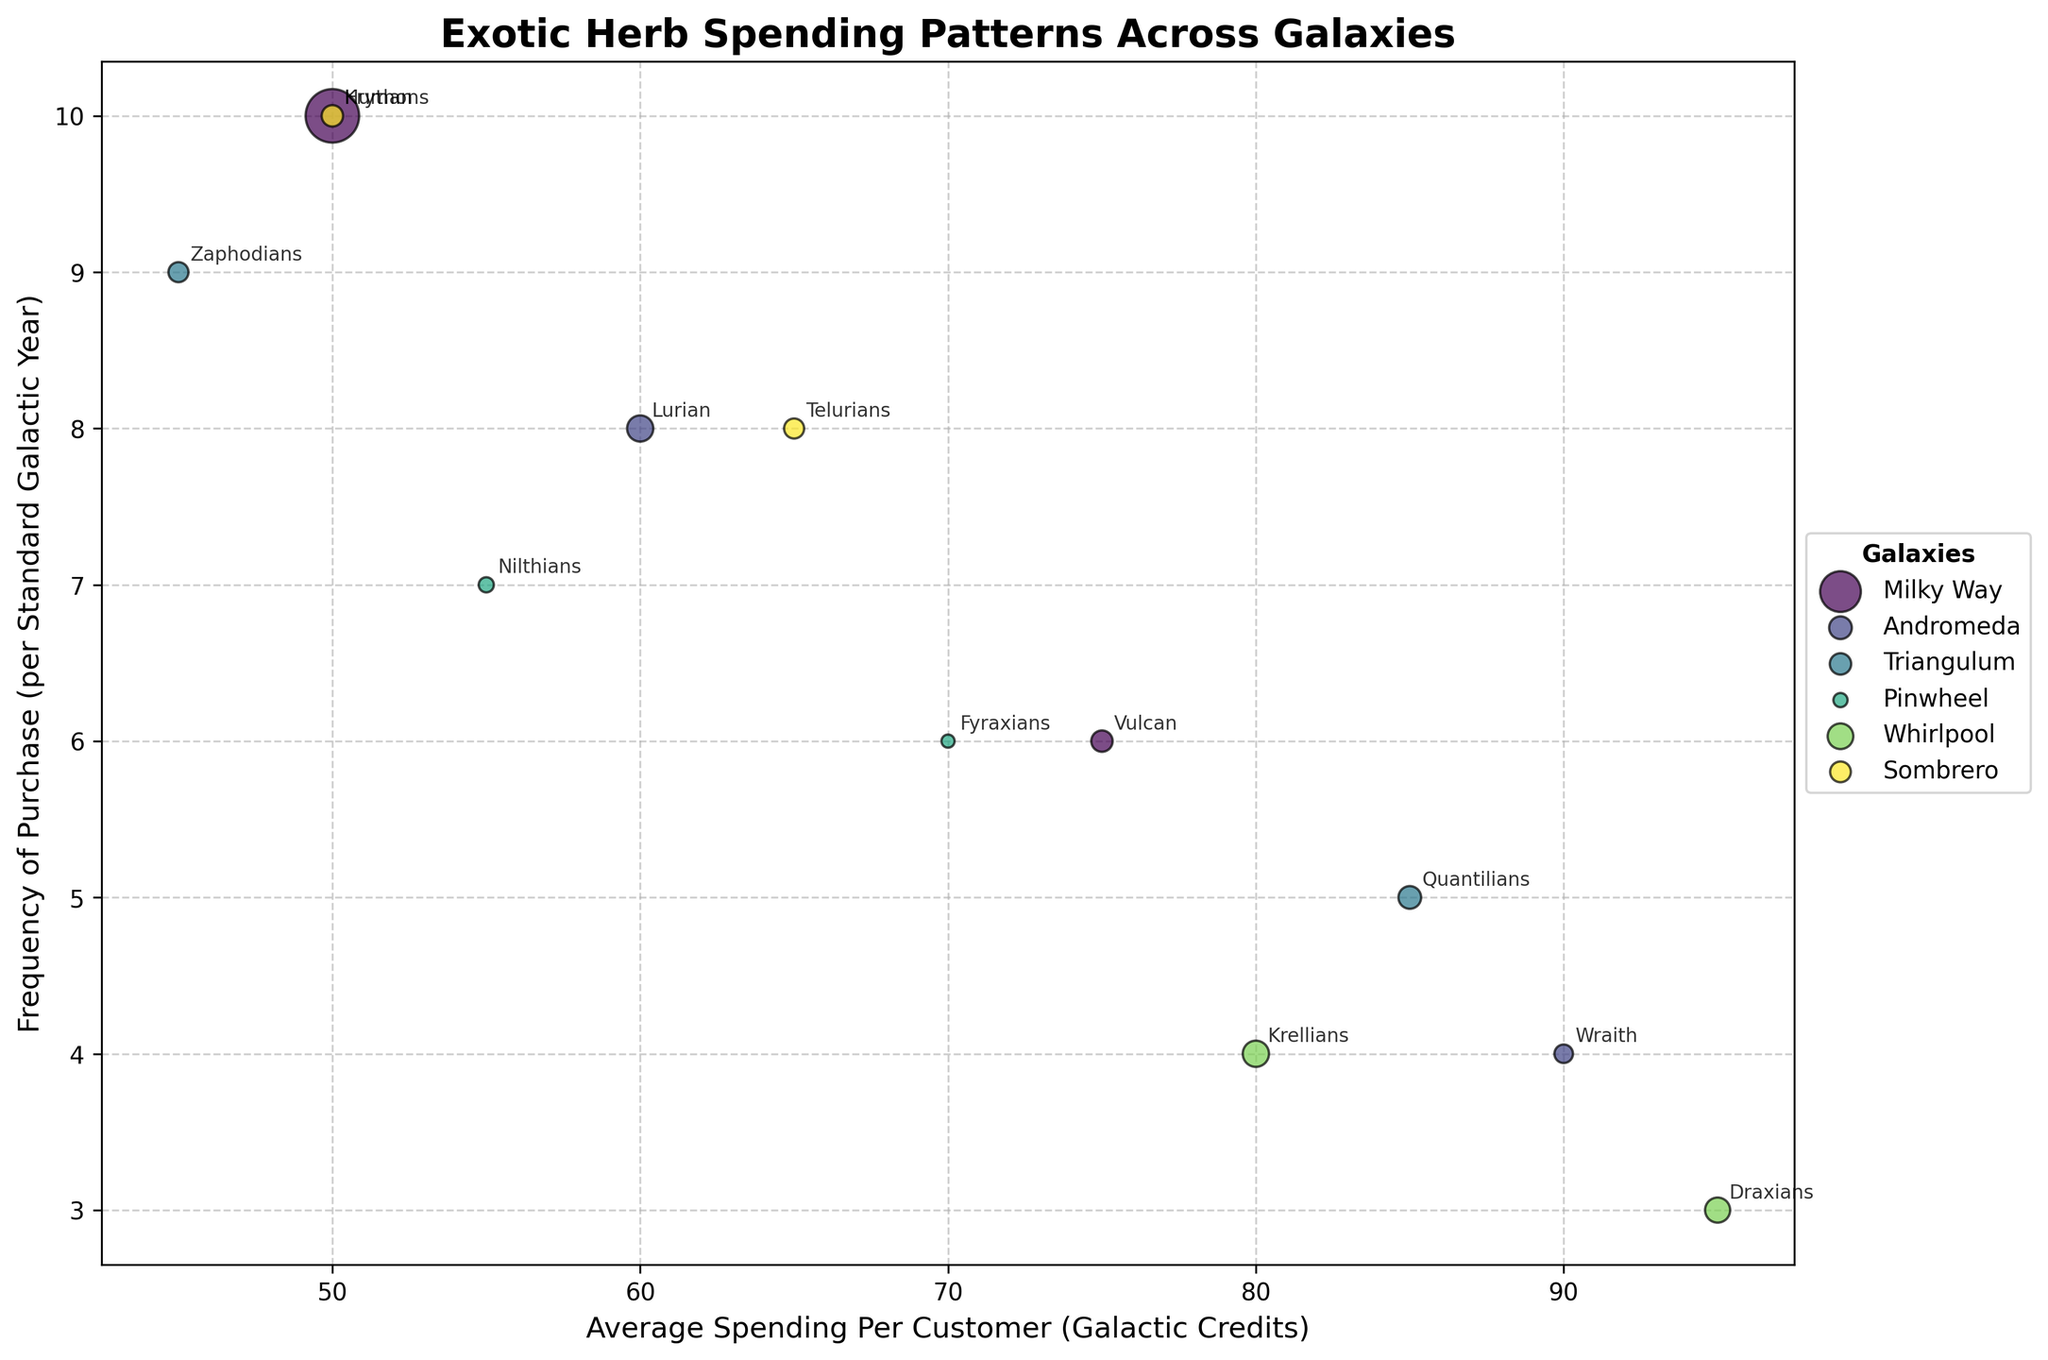What's the average spending per customer for the species with the highest frequency of purchase? The Krythons have the highest frequency of purchase at 10 times per year. Referring to their average spending per customer, they spend 50 Galactic Credits per customer annually.
Answer: 50 Galactic Credits Which galaxy has the most diverse species represented in the figure? By counting unique species per galaxy: Milky Way has 2, Andromeda has 2, Triangulum has 2, Pinwheel has 2, Whirlpool has 2, and Sombrero has 2. Each galaxy has an equal number of 2 unique species.
Answer: Equal (2 species each) Which species from the Milky Way has a higher average spending per customer? From the Milky Way galaxy, Humans spend 50 Galactic Credits, and Vulcans spend 75 Galactic Credits per customer on average. Thus, Vulcans have a higher average spending per customer.
Answer: Vulcans Among species that purchase herbs 6 times per year, which one has the higher average spending per customer? Vulcans from the Milky Way galaxy and Fyraxians from the Pinwheel galaxy both have a purchase frequency of 6. Vulcans spend 75 Galactic Credits, and Fyraxians spend 70 Galactic Credits on average. Therefore, Vulcans have the higher spending.
Answer: Vulcans Which species has the highest average spending per customer in the Whirlpool galaxy? In the Whirlpool galaxy, there are Draxians who spend 95 Galactic Credits and Krellians who spend 80 Galactic Credits per customer on average. Draxians have the highest spending.
Answer: Draxians What is the total customer count for all species in the Triangulum galaxy? In the Triangulum galaxy, Zaphodians have 700 customers and Quantilians have 900 customers. Adding these counts: 700 + 900 = 1600 customers.
Answer: 1600 customers Which species has the lowest purchase frequency but higher spending than Draxians? Draxians have a frequency of 3 and an average spending of 95 Galactic Credits. To find a species with a higher average spending and the same or lower purchase frequency: no species fits these criteria as Draxians have the highest spending in the dataset.
Answer: None In the Andromeda galaxy, which species has a higher frequency of purchase, and how much do they spend differently compared to the other species in the same galaxy? Comparing Lurians and Wraiths in the Andromeda galaxy, Lurians have a purchase frequency of 8, while Wraiths have a frequency of 4. Lurians spend 60 Galactic Credits, and Wraiths spend 90 Galactic Credits. The difference in spending: 90 - 60 = 30 Galactic Credits.
Answer: Lurians, 30 Galactic Credits Identify a species with a frequency of purchase equal to that of Vulcans and a higher average spending than Humans. Vulcans purchase herbs 6 times a year, and Humans have an average spending of 50 Galactic Credits. Fyraxians also have a purchase frequency of 6 and an average spending of 70 Galactic Credits, which is higher than that of Humans.
Answer: Fyraxians 